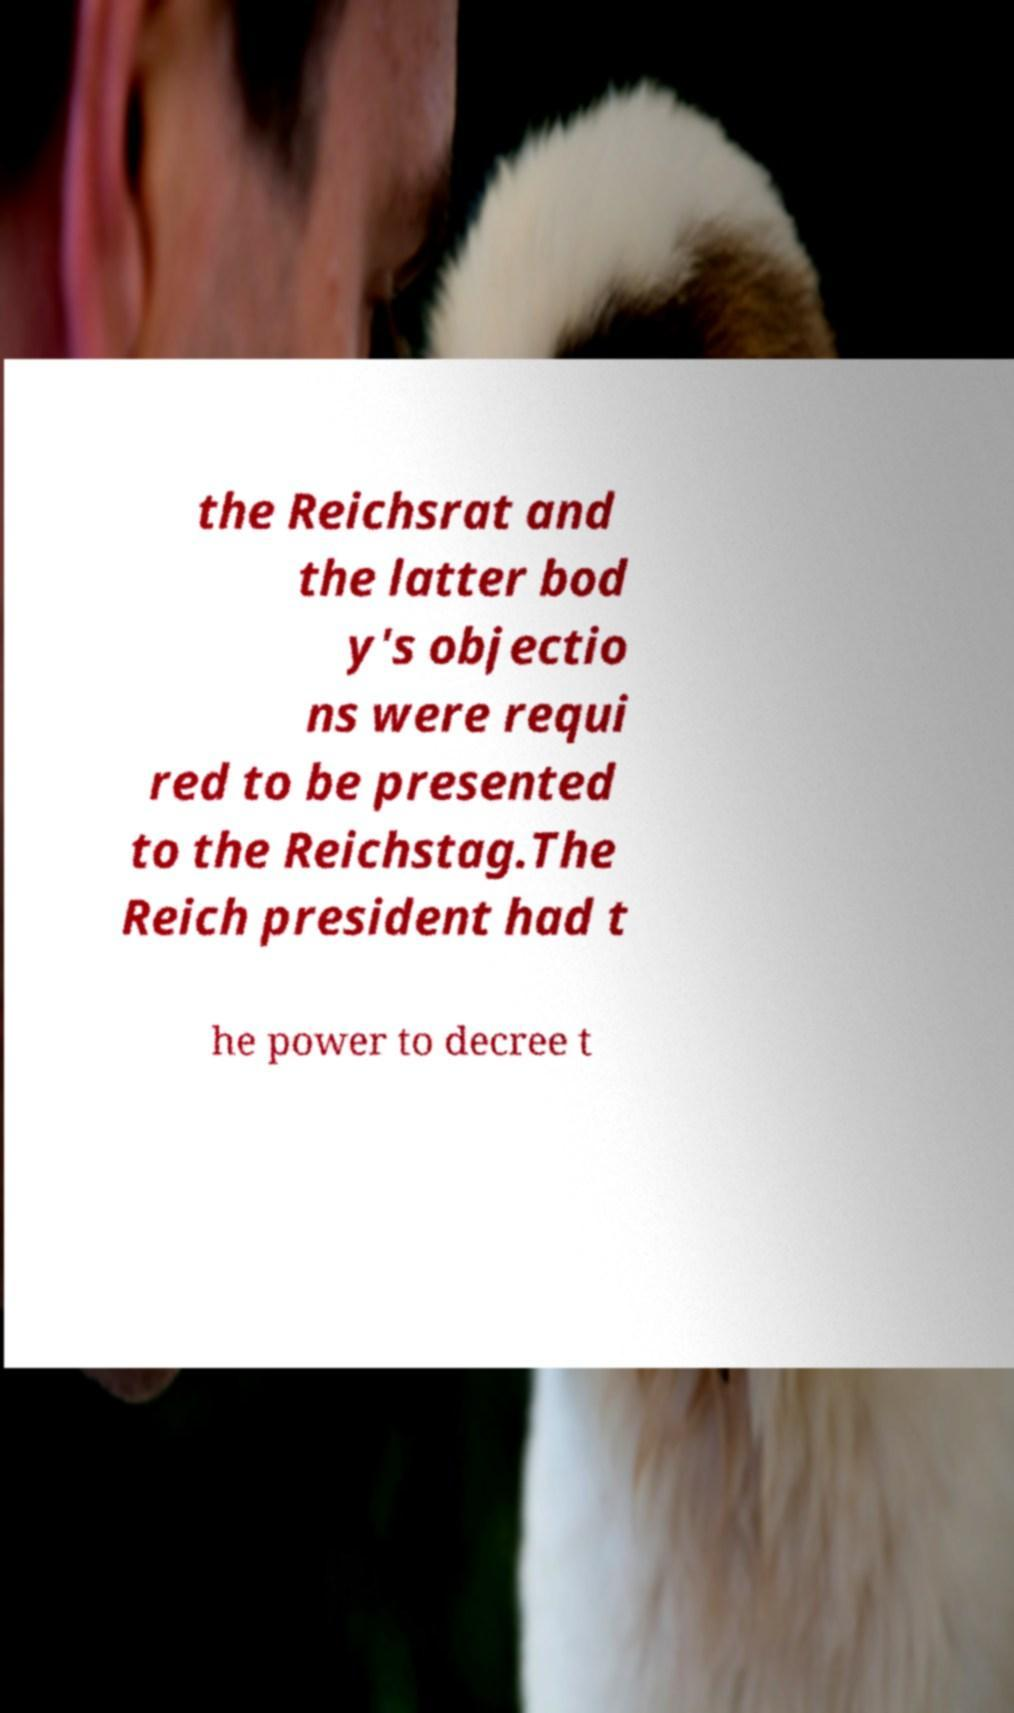Can you read and provide the text displayed in the image?This photo seems to have some interesting text. Can you extract and type it out for me? the Reichsrat and the latter bod y's objectio ns were requi red to be presented to the Reichstag.The Reich president had t he power to decree t 